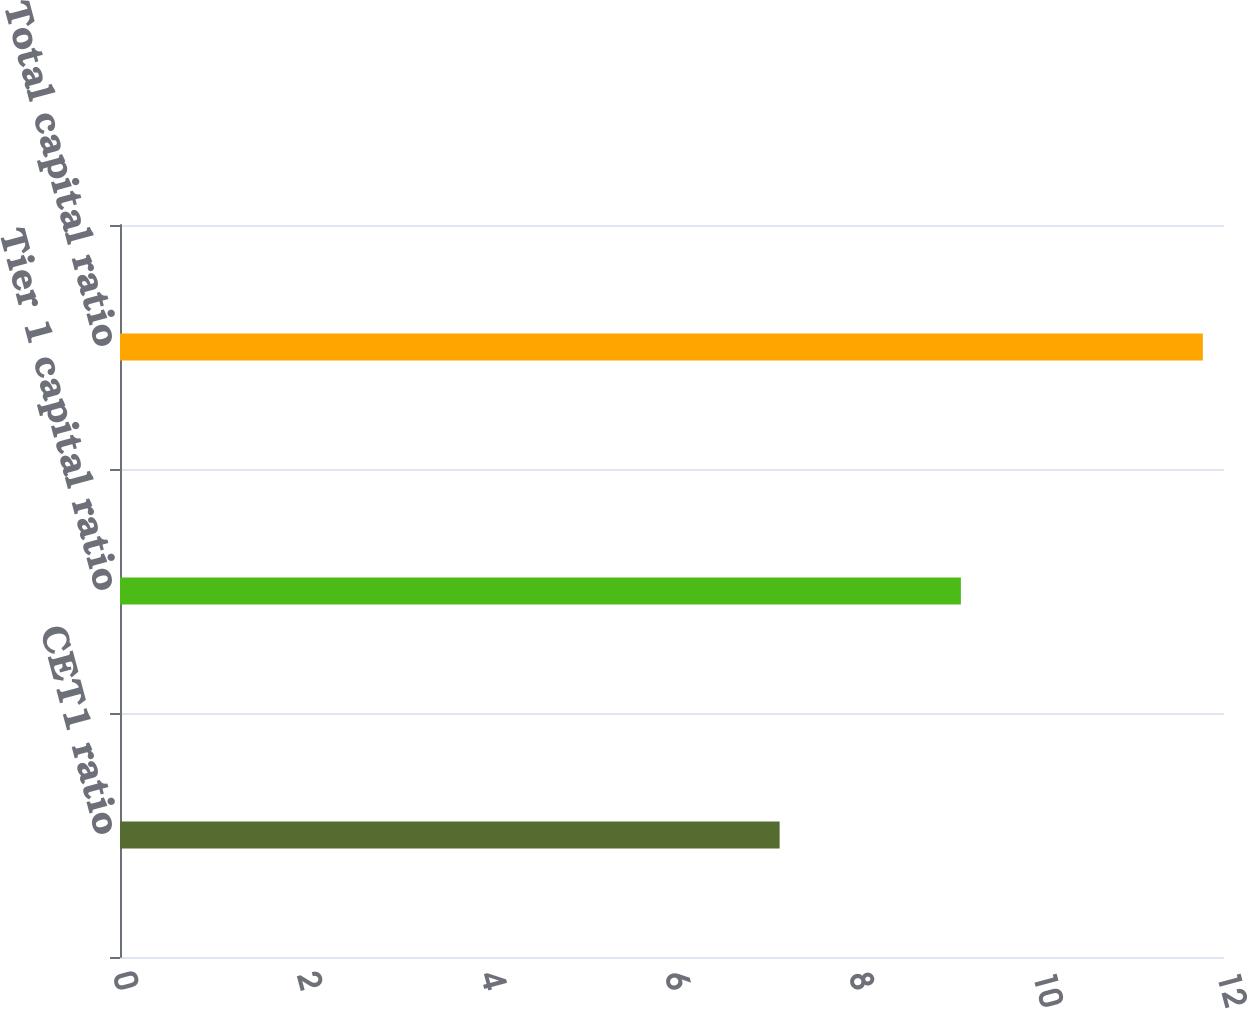<chart> <loc_0><loc_0><loc_500><loc_500><bar_chart><fcel>CET1 ratio<fcel>Tier 1 capital ratio<fcel>Total capital ratio<nl><fcel>7.17<fcel>9.14<fcel>11.77<nl></chart> 